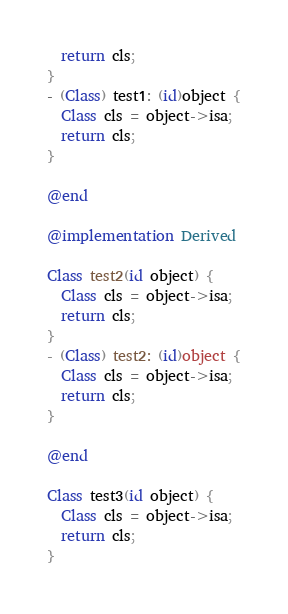<code> <loc_0><loc_0><loc_500><loc_500><_ObjectiveC_>  return cls;
}
- (Class) test1: (id)object {
  Class cls = object->isa;
  return cls;
}

@end

@implementation Derived

Class test2(id object) {
  Class cls = object->isa;
  return cls;
}
- (Class) test2: (id)object {
  Class cls = object->isa;
  return cls;
}

@end

Class test3(id object) {
  Class cls = object->isa;
  return cls;
}
</code> 